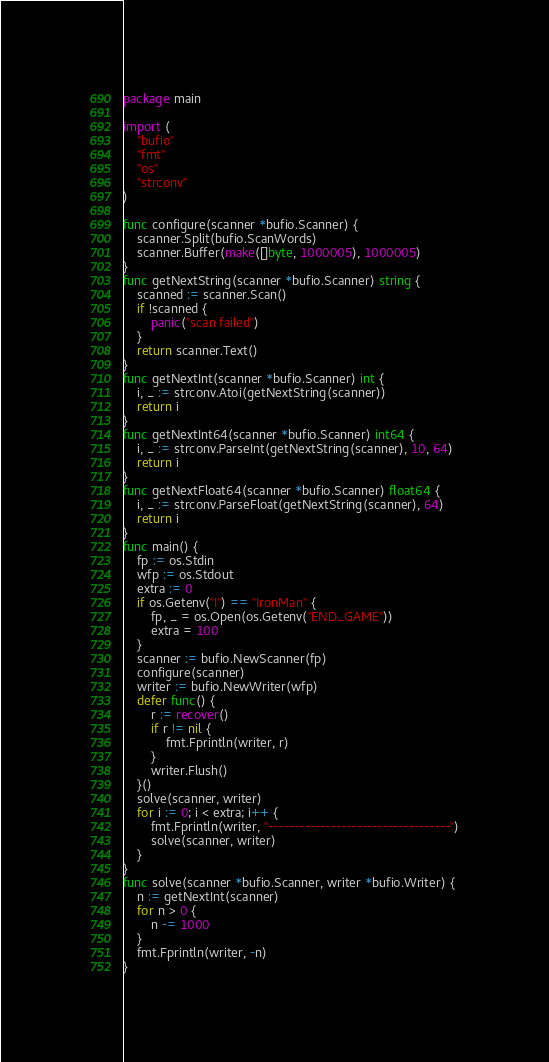<code> <loc_0><loc_0><loc_500><loc_500><_Go_>package main

import (
	"bufio"
	"fmt"
	"os"
	"strconv"
)

func configure(scanner *bufio.Scanner) {
	scanner.Split(bufio.ScanWords)
	scanner.Buffer(make([]byte, 1000005), 1000005)
}
func getNextString(scanner *bufio.Scanner) string {
	scanned := scanner.Scan()
	if !scanned {
		panic("scan failed")
	}
	return scanner.Text()
}
func getNextInt(scanner *bufio.Scanner) int {
	i, _ := strconv.Atoi(getNextString(scanner))
	return i
}
func getNextInt64(scanner *bufio.Scanner) int64 {
	i, _ := strconv.ParseInt(getNextString(scanner), 10, 64)
	return i
}
func getNextFloat64(scanner *bufio.Scanner) float64 {
	i, _ := strconv.ParseFloat(getNextString(scanner), 64)
	return i
}
func main() {
	fp := os.Stdin
	wfp := os.Stdout
	extra := 0
	if os.Getenv("I") == "IronMan" {
		fp, _ = os.Open(os.Getenv("END_GAME"))
		extra = 100
	}
	scanner := bufio.NewScanner(fp)
	configure(scanner)
	writer := bufio.NewWriter(wfp)
	defer func() {
		r := recover()
		if r != nil {
			fmt.Fprintln(writer, r)
		}
		writer.Flush()
	}()
	solve(scanner, writer)
	for i := 0; i < extra; i++ {
		fmt.Fprintln(writer, "-----------------------------------")
		solve(scanner, writer)
	}
}
func solve(scanner *bufio.Scanner, writer *bufio.Writer) {
	n := getNextInt(scanner)
	for n > 0 {
		n -= 1000
	}
	fmt.Fprintln(writer, -n)
}
</code> 